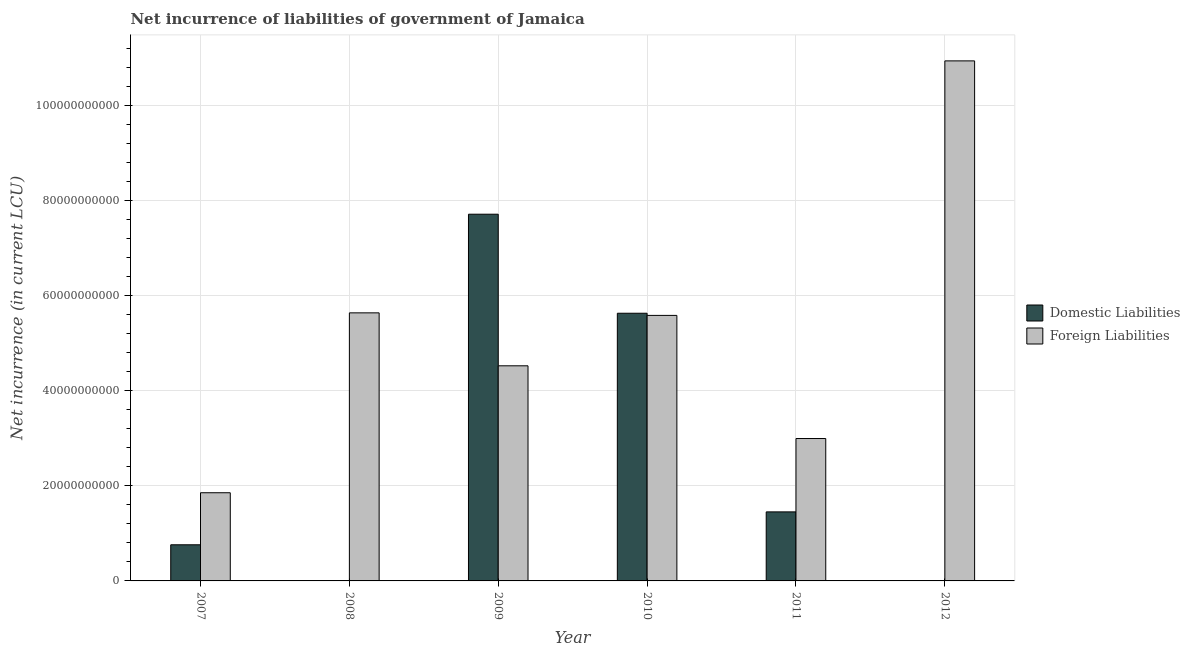Are the number of bars per tick equal to the number of legend labels?
Make the answer very short. No. What is the label of the 2nd group of bars from the left?
Your response must be concise. 2008. What is the net incurrence of domestic liabilities in 2009?
Your answer should be very brief. 7.71e+1. Across all years, what is the maximum net incurrence of domestic liabilities?
Ensure brevity in your answer.  7.71e+1. Across all years, what is the minimum net incurrence of foreign liabilities?
Ensure brevity in your answer.  1.85e+1. In which year was the net incurrence of domestic liabilities maximum?
Give a very brief answer. 2009. What is the total net incurrence of domestic liabilities in the graph?
Your response must be concise. 1.55e+11. What is the difference between the net incurrence of foreign liabilities in 2007 and that in 2011?
Your response must be concise. -1.14e+1. What is the difference between the net incurrence of domestic liabilities in 2012 and the net incurrence of foreign liabilities in 2010?
Offer a terse response. -5.63e+1. What is the average net incurrence of foreign liabilities per year?
Make the answer very short. 5.25e+1. What is the ratio of the net incurrence of foreign liabilities in 2008 to that in 2010?
Your response must be concise. 1.01. What is the difference between the highest and the second highest net incurrence of domestic liabilities?
Make the answer very short. 2.08e+1. What is the difference between the highest and the lowest net incurrence of foreign liabilities?
Provide a short and direct response. 9.08e+1. Is the sum of the net incurrence of foreign liabilities in 2007 and 2011 greater than the maximum net incurrence of domestic liabilities across all years?
Ensure brevity in your answer.  No. How many bars are there?
Make the answer very short. 10. Are all the bars in the graph horizontal?
Offer a terse response. No. Are the values on the major ticks of Y-axis written in scientific E-notation?
Ensure brevity in your answer.  No. Does the graph contain any zero values?
Provide a succinct answer. Yes. What is the title of the graph?
Keep it short and to the point. Net incurrence of liabilities of government of Jamaica. What is the label or title of the X-axis?
Offer a very short reply. Year. What is the label or title of the Y-axis?
Your answer should be compact. Net incurrence (in current LCU). What is the Net incurrence (in current LCU) in Domestic Liabilities in 2007?
Your response must be concise. 7.60e+09. What is the Net incurrence (in current LCU) of Foreign Liabilities in 2007?
Your response must be concise. 1.85e+1. What is the Net incurrence (in current LCU) in Foreign Liabilities in 2008?
Provide a short and direct response. 5.64e+1. What is the Net incurrence (in current LCU) of Domestic Liabilities in 2009?
Offer a very short reply. 7.71e+1. What is the Net incurrence (in current LCU) of Foreign Liabilities in 2009?
Offer a terse response. 4.52e+1. What is the Net incurrence (in current LCU) in Domestic Liabilities in 2010?
Offer a very short reply. 5.63e+1. What is the Net incurrence (in current LCU) of Foreign Liabilities in 2010?
Ensure brevity in your answer.  5.58e+1. What is the Net incurrence (in current LCU) of Domestic Liabilities in 2011?
Offer a very short reply. 1.45e+1. What is the Net incurrence (in current LCU) of Foreign Liabilities in 2011?
Your response must be concise. 2.99e+1. What is the Net incurrence (in current LCU) in Foreign Liabilities in 2012?
Offer a very short reply. 1.09e+11. Across all years, what is the maximum Net incurrence (in current LCU) of Domestic Liabilities?
Provide a succinct answer. 7.71e+1. Across all years, what is the maximum Net incurrence (in current LCU) of Foreign Liabilities?
Your answer should be compact. 1.09e+11. Across all years, what is the minimum Net incurrence (in current LCU) in Foreign Liabilities?
Provide a short and direct response. 1.85e+1. What is the total Net incurrence (in current LCU) in Domestic Liabilities in the graph?
Your answer should be very brief. 1.55e+11. What is the total Net incurrence (in current LCU) in Foreign Liabilities in the graph?
Provide a succinct answer. 3.15e+11. What is the difference between the Net incurrence (in current LCU) in Foreign Liabilities in 2007 and that in 2008?
Ensure brevity in your answer.  -3.78e+1. What is the difference between the Net incurrence (in current LCU) of Domestic Liabilities in 2007 and that in 2009?
Your response must be concise. -6.95e+1. What is the difference between the Net incurrence (in current LCU) of Foreign Liabilities in 2007 and that in 2009?
Keep it short and to the point. -2.67e+1. What is the difference between the Net incurrence (in current LCU) of Domestic Liabilities in 2007 and that in 2010?
Keep it short and to the point. -4.87e+1. What is the difference between the Net incurrence (in current LCU) of Foreign Liabilities in 2007 and that in 2010?
Your answer should be compact. -3.73e+1. What is the difference between the Net incurrence (in current LCU) of Domestic Liabilities in 2007 and that in 2011?
Provide a succinct answer. -6.92e+09. What is the difference between the Net incurrence (in current LCU) of Foreign Liabilities in 2007 and that in 2011?
Offer a terse response. -1.14e+1. What is the difference between the Net incurrence (in current LCU) of Foreign Liabilities in 2007 and that in 2012?
Your answer should be compact. -9.08e+1. What is the difference between the Net incurrence (in current LCU) of Foreign Liabilities in 2008 and that in 2009?
Provide a short and direct response. 1.11e+1. What is the difference between the Net incurrence (in current LCU) in Foreign Liabilities in 2008 and that in 2010?
Give a very brief answer. 5.38e+08. What is the difference between the Net incurrence (in current LCU) in Foreign Liabilities in 2008 and that in 2011?
Give a very brief answer. 2.64e+1. What is the difference between the Net incurrence (in current LCU) of Foreign Liabilities in 2008 and that in 2012?
Offer a very short reply. -5.30e+1. What is the difference between the Net incurrence (in current LCU) of Domestic Liabilities in 2009 and that in 2010?
Your response must be concise. 2.08e+1. What is the difference between the Net incurrence (in current LCU) in Foreign Liabilities in 2009 and that in 2010?
Offer a very short reply. -1.06e+1. What is the difference between the Net incurrence (in current LCU) of Domestic Liabilities in 2009 and that in 2011?
Your response must be concise. 6.26e+1. What is the difference between the Net incurrence (in current LCU) of Foreign Liabilities in 2009 and that in 2011?
Your answer should be compact. 1.53e+1. What is the difference between the Net incurrence (in current LCU) in Foreign Liabilities in 2009 and that in 2012?
Provide a succinct answer. -6.41e+1. What is the difference between the Net incurrence (in current LCU) of Domestic Liabilities in 2010 and that in 2011?
Provide a short and direct response. 4.18e+1. What is the difference between the Net incurrence (in current LCU) of Foreign Liabilities in 2010 and that in 2011?
Your answer should be very brief. 2.59e+1. What is the difference between the Net incurrence (in current LCU) in Foreign Liabilities in 2010 and that in 2012?
Your answer should be compact. -5.35e+1. What is the difference between the Net incurrence (in current LCU) in Foreign Liabilities in 2011 and that in 2012?
Your answer should be very brief. -7.94e+1. What is the difference between the Net incurrence (in current LCU) of Domestic Liabilities in 2007 and the Net incurrence (in current LCU) of Foreign Liabilities in 2008?
Your answer should be compact. -4.88e+1. What is the difference between the Net incurrence (in current LCU) of Domestic Liabilities in 2007 and the Net incurrence (in current LCU) of Foreign Liabilities in 2009?
Ensure brevity in your answer.  -3.76e+1. What is the difference between the Net incurrence (in current LCU) of Domestic Liabilities in 2007 and the Net incurrence (in current LCU) of Foreign Liabilities in 2010?
Your answer should be compact. -4.82e+1. What is the difference between the Net incurrence (in current LCU) in Domestic Liabilities in 2007 and the Net incurrence (in current LCU) in Foreign Liabilities in 2011?
Give a very brief answer. -2.23e+1. What is the difference between the Net incurrence (in current LCU) in Domestic Liabilities in 2007 and the Net incurrence (in current LCU) in Foreign Liabilities in 2012?
Your response must be concise. -1.02e+11. What is the difference between the Net incurrence (in current LCU) in Domestic Liabilities in 2009 and the Net incurrence (in current LCU) in Foreign Liabilities in 2010?
Provide a short and direct response. 2.13e+1. What is the difference between the Net incurrence (in current LCU) of Domestic Liabilities in 2009 and the Net incurrence (in current LCU) of Foreign Liabilities in 2011?
Give a very brief answer. 4.72e+1. What is the difference between the Net incurrence (in current LCU) of Domestic Liabilities in 2009 and the Net incurrence (in current LCU) of Foreign Liabilities in 2012?
Provide a succinct answer. -3.22e+1. What is the difference between the Net incurrence (in current LCU) in Domestic Liabilities in 2010 and the Net incurrence (in current LCU) in Foreign Liabilities in 2011?
Offer a very short reply. 2.63e+1. What is the difference between the Net incurrence (in current LCU) of Domestic Liabilities in 2010 and the Net incurrence (in current LCU) of Foreign Liabilities in 2012?
Your response must be concise. -5.31e+1. What is the difference between the Net incurrence (in current LCU) of Domestic Liabilities in 2011 and the Net incurrence (in current LCU) of Foreign Liabilities in 2012?
Give a very brief answer. -9.48e+1. What is the average Net incurrence (in current LCU) of Domestic Liabilities per year?
Make the answer very short. 2.59e+1. What is the average Net incurrence (in current LCU) in Foreign Liabilities per year?
Ensure brevity in your answer.  5.25e+1. In the year 2007, what is the difference between the Net incurrence (in current LCU) in Domestic Liabilities and Net incurrence (in current LCU) in Foreign Liabilities?
Give a very brief answer. -1.09e+1. In the year 2009, what is the difference between the Net incurrence (in current LCU) in Domestic Liabilities and Net incurrence (in current LCU) in Foreign Liabilities?
Provide a short and direct response. 3.19e+1. In the year 2010, what is the difference between the Net incurrence (in current LCU) of Domestic Liabilities and Net incurrence (in current LCU) of Foreign Liabilities?
Ensure brevity in your answer.  4.55e+08. In the year 2011, what is the difference between the Net incurrence (in current LCU) of Domestic Liabilities and Net incurrence (in current LCU) of Foreign Liabilities?
Provide a succinct answer. -1.54e+1. What is the ratio of the Net incurrence (in current LCU) in Foreign Liabilities in 2007 to that in 2008?
Make the answer very short. 0.33. What is the ratio of the Net incurrence (in current LCU) of Domestic Liabilities in 2007 to that in 2009?
Offer a very short reply. 0.1. What is the ratio of the Net incurrence (in current LCU) of Foreign Liabilities in 2007 to that in 2009?
Offer a very short reply. 0.41. What is the ratio of the Net incurrence (in current LCU) of Domestic Liabilities in 2007 to that in 2010?
Offer a terse response. 0.14. What is the ratio of the Net incurrence (in current LCU) of Foreign Liabilities in 2007 to that in 2010?
Your answer should be very brief. 0.33. What is the ratio of the Net incurrence (in current LCU) of Domestic Liabilities in 2007 to that in 2011?
Offer a very short reply. 0.52. What is the ratio of the Net incurrence (in current LCU) in Foreign Liabilities in 2007 to that in 2011?
Offer a very short reply. 0.62. What is the ratio of the Net incurrence (in current LCU) in Foreign Liabilities in 2007 to that in 2012?
Your answer should be compact. 0.17. What is the ratio of the Net incurrence (in current LCU) of Foreign Liabilities in 2008 to that in 2009?
Offer a terse response. 1.25. What is the ratio of the Net incurrence (in current LCU) in Foreign Liabilities in 2008 to that in 2010?
Give a very brief answer. 1.01. What is the ratio of the Net incurrence (in current LCU) in Foreign Liabilities in 2008 to that in 2011?
Make the answer very short. 1.88. What is the ratio of the Net incurrence (in current LCU) in Foreign Liabilities in 2008 to that in 2012?
Offer a terse response. 0.52. What is the ratio of the Net incurrence (in current LCU) of Domestic Liabilities in 2009 to that in 2010?
Make the answer very short. 1.37. What is the ratio of the Net incurrence (in current LCU) of Foreign Liabilities in 2009 to that in 2010?
Offer a terse response. 0.81. What is the ratio of the Net incurrence (in current LCU) in Domestic Liabilities in 2009 to that in 2011?
Give a very brief answer. 5.31. What is the ratio of the Net incurrence (in current LCU) in Foreign Liabilities in 2009 to that in 2011?
Your answer should be very brief. 1.51. What is the ratio of the Net incurrence (in current LCU) of Foreign Liabilities in 2009 to that in 2012?
Your response must be concise. 0.41. What is the ratio of the Net incurrence (in current LCU) of Domestic Liabilities in 2010 to that in 2011?
Give a very brief answer. 3.88. What is the ratio of the Net incurrence (in current LCU) in Foreign Liabilities in 2010 to that in 2011?
Your response must be concise. 1.86. What is the ratio of the Net incurrence (in current LCU) of Foreign Liabilities in 2010 to that in 2012?
Make the answer very short. 0.51. What is the ratio of the Net incurrence (in current LCU) in Foreign Liabilities in 2011 to that in 2012?
Ensure brevity in your answer.  0.27. What is the difference between the highest and the second highest Net incurrence (in current LCU) in Domestic Liabilities?
Offer a terse response. 2.08e+1. What is the difference between the highest and the second highest Net incurrence (in current LCU) in Foreign Liabilities?
Offer a very short reply. 5.30e+1. What is the difference between the highest and the lowest Net incurrence (in current LCU) of Domestic Liabilities?
Make the answer very short. 7.71e+1. What is the difference between the highest and the lowest Net incurrence (in current LCU) in Foreign Liabilities?
Provide a short and direct response. 9.08e+1. 